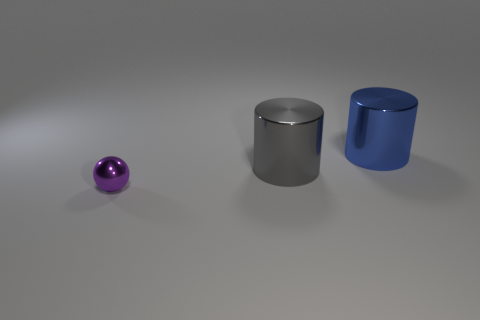There is a large metallic thing left of the big blue metal cylinder; is its color the same as the small metallic sphere?
Give a very brief answer. No. There is a thing in front of the large gray metal thing; what size is it?
Offer a terse response. Small. There is a thing in front of the cylinder in front of the big blue thing; what shape is it?
Your response must be concise. Sphere. What is the color of the other thing that is the same shape as the big blue shiny object?
Provide a succinct answer. Gray. There is a metallic cylinder to the left of the blue shiny thing; does it have the same size as the purple metal thing?
Your answer should be compact. No. What number of other blue cylinders are the same material as the large blue cylinder?
Give a very brief answer. 0. The large cylinder that is left of the cylinder behind the large metal cylinder that is left of the blue object is made of what material?
Your answer should be compact. Metal. The thing that is on the left side of the big metal cylinder that is in front of the large blue cylinder is what color?
Make the answer very short. Purple. What color is the other thing that is the same size as the blue thing?
Your answer should be very brief. Gray. How many large objects are either green metallic cylinders or purple things?
Your response must be concise. 0. 